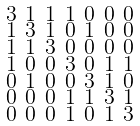Convert formula to latex. <formula><loc_0><loc_0><loc_500><loc_500>\begin{smallmatrix} 3 & 1 & 1 & 1 & 0 & 0 & 0 \\ 1 & 3 & 1 & 0 & 1 & 0 & 0 \\ 1 & 1 & 3 & 0 & 0 & 0 & 0 \\ 1 & 0 & 0 & 3 & 0 & 1 & 1 \\ 0 & 1 & 0 & 0 & 3 & 1 & 0 \\ 0 & 0 & 0 & 1 & 1 & 3 & 1 \\ 0 & 0 & 0 & 1 & 0 & 1 & 3 \end{smallmatrix}</formula> 